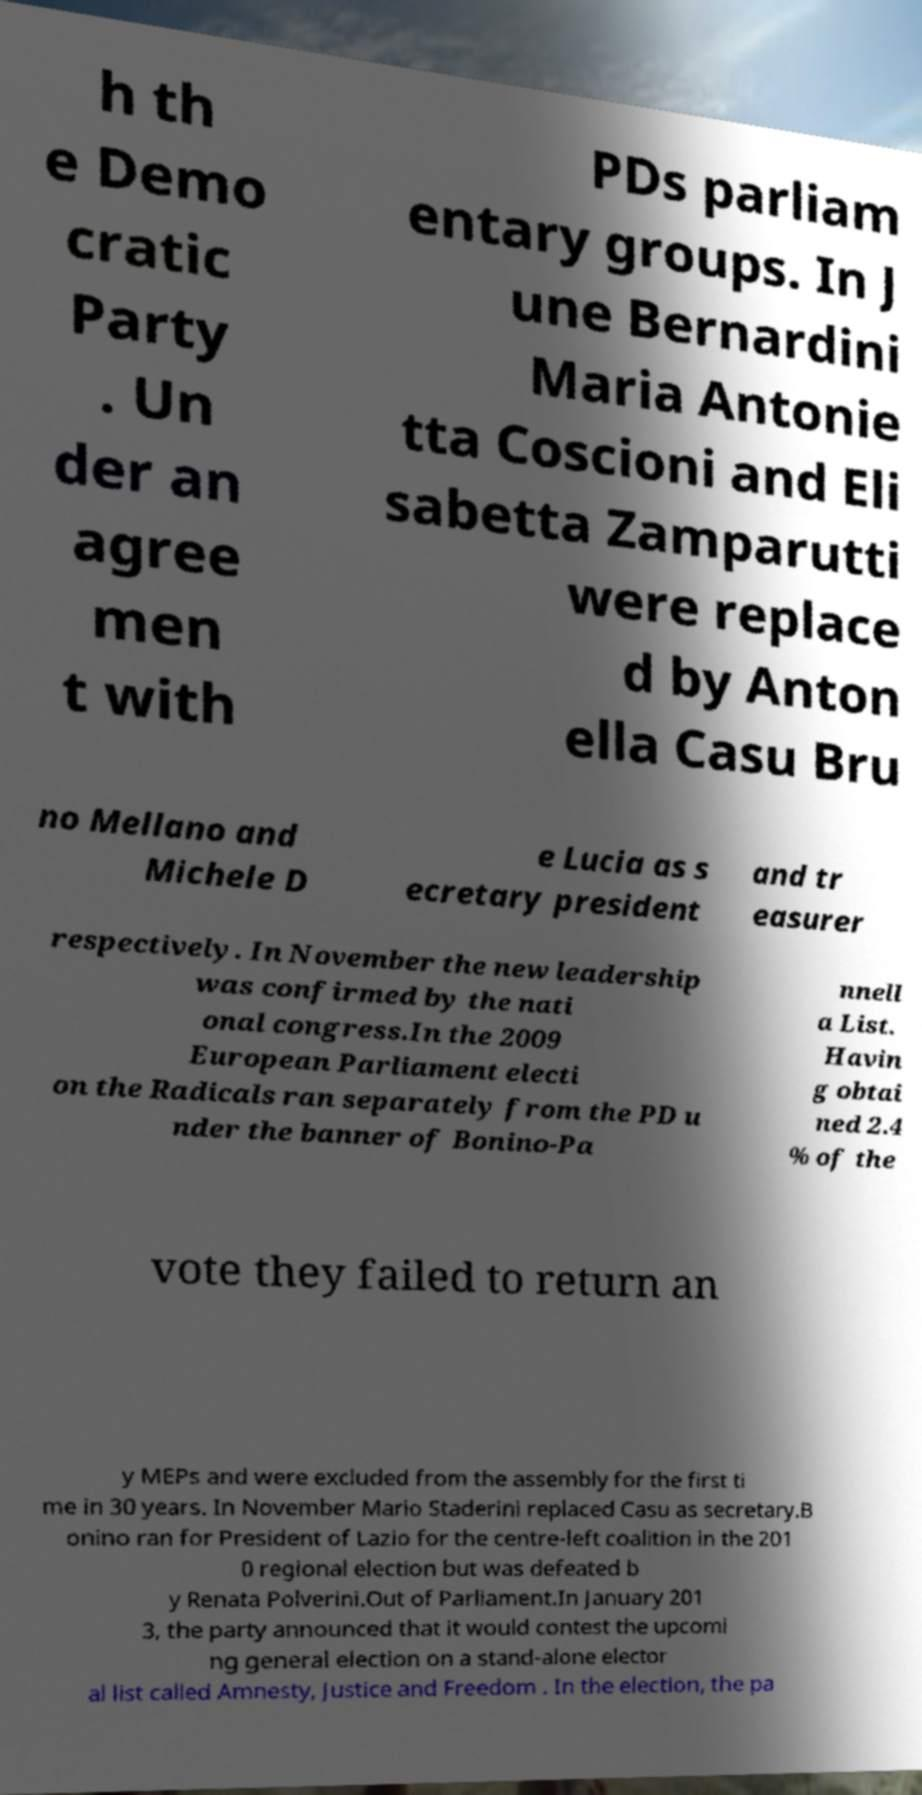What messages or text are displayed in this image? I need them in a readable, typed format. h th e Demo cratic Party . Un der an agree men t with PDs parliam entary groups. In J une Bernardini Maria Antonie tta Coscioni and Eli sabetta Zamparutti were replace d by Anton ella Casu Bru no Mellano and Michele D e Lucia as s ecretary president and tr easurer respectively. In November the new leadership was confirmed by the nati onal congress.In the 2009 European Parliament electi on the Radicals ran separately from the PD u nder the banner of Bonino-Pa nnell a List. Havin g obtai ned 2.4 % of the vote they failed to return an y MEPs and were excluded from the assembly for the first ti me in 30 years. In November Mario Staderini replaced Casu as secretary.B onino ran for President of Lazio for the centre-left coalition in the 201 0 regional election but was defeated b y Renata Polverini.Out of Parliament.In January 201 3, the party announced that it would contest the upcomi ng general election on a stand-alone elector al list called Amnesty, Justice and Freedom . In the election, the pa 